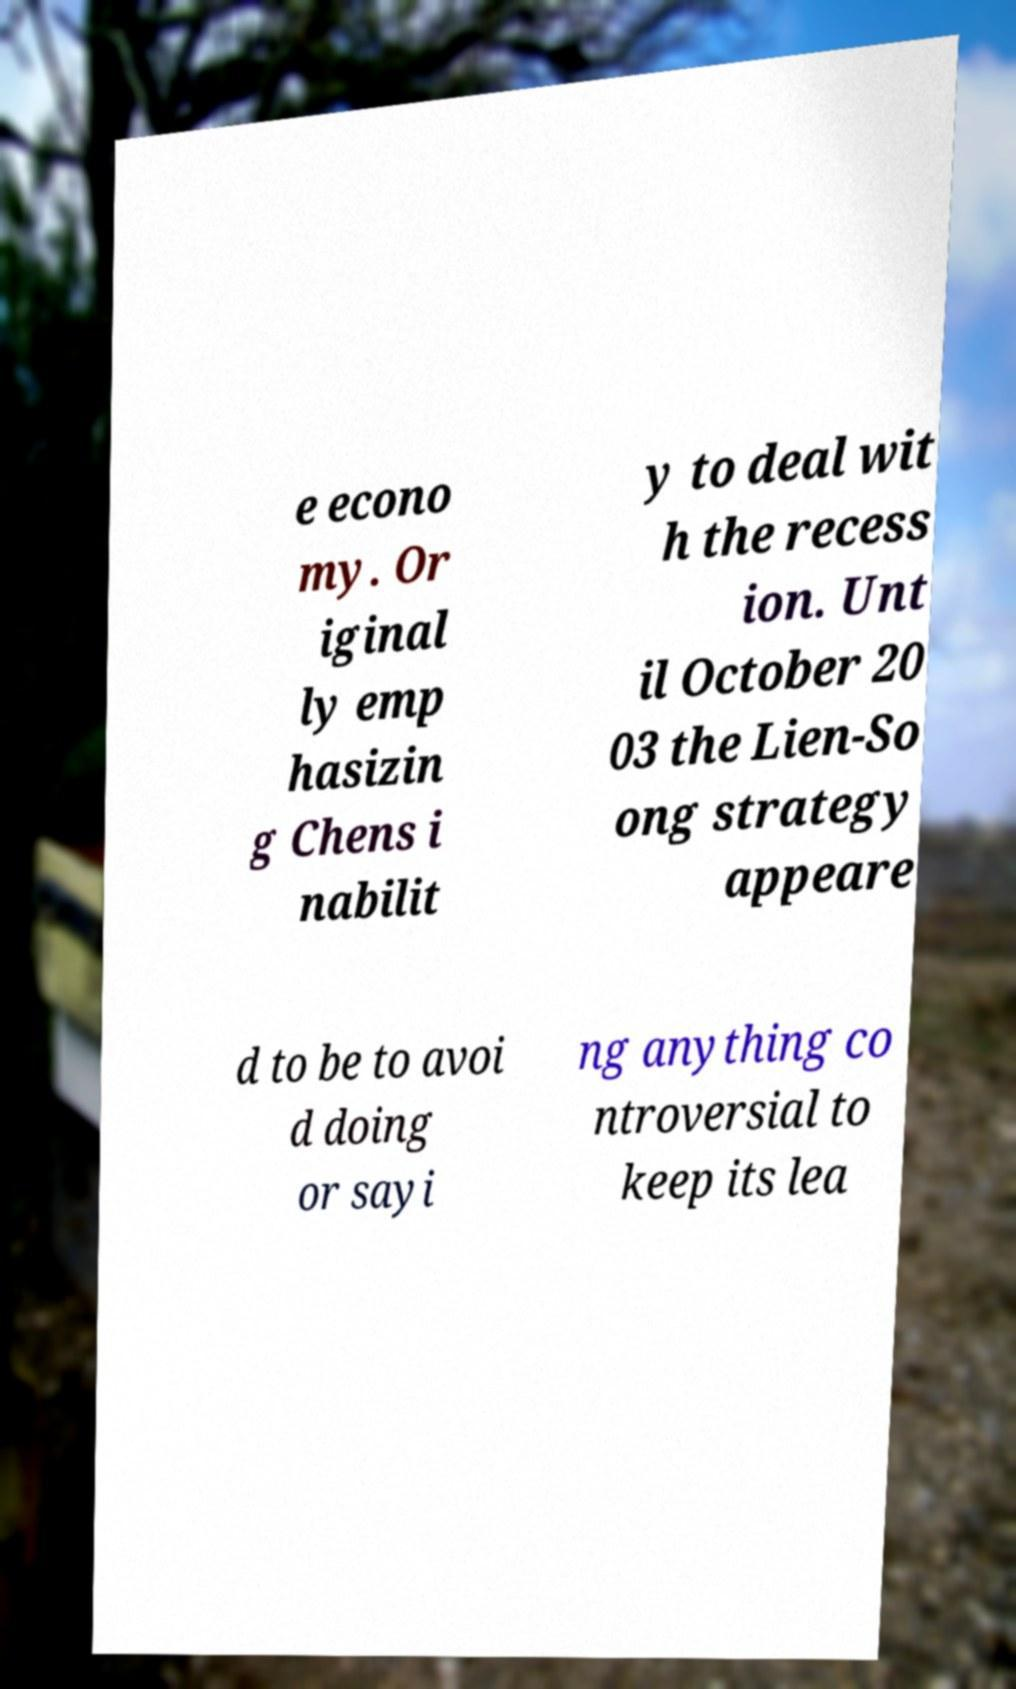Please read and relay the text visible in this image. What does it say? e econo my. Or iginal ly emp hasizin g Chens i nabilit y to deal wit h the recess ion. Unt il October 20 03 the Lien-So ong strategy appeare d to be to avoi d doing or sayi ng anything co ntroversial to keep its lea 